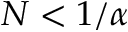<formula> <loc_0><loc_0><loc_500><loc_500>N < 1 / \alpha</formula> 